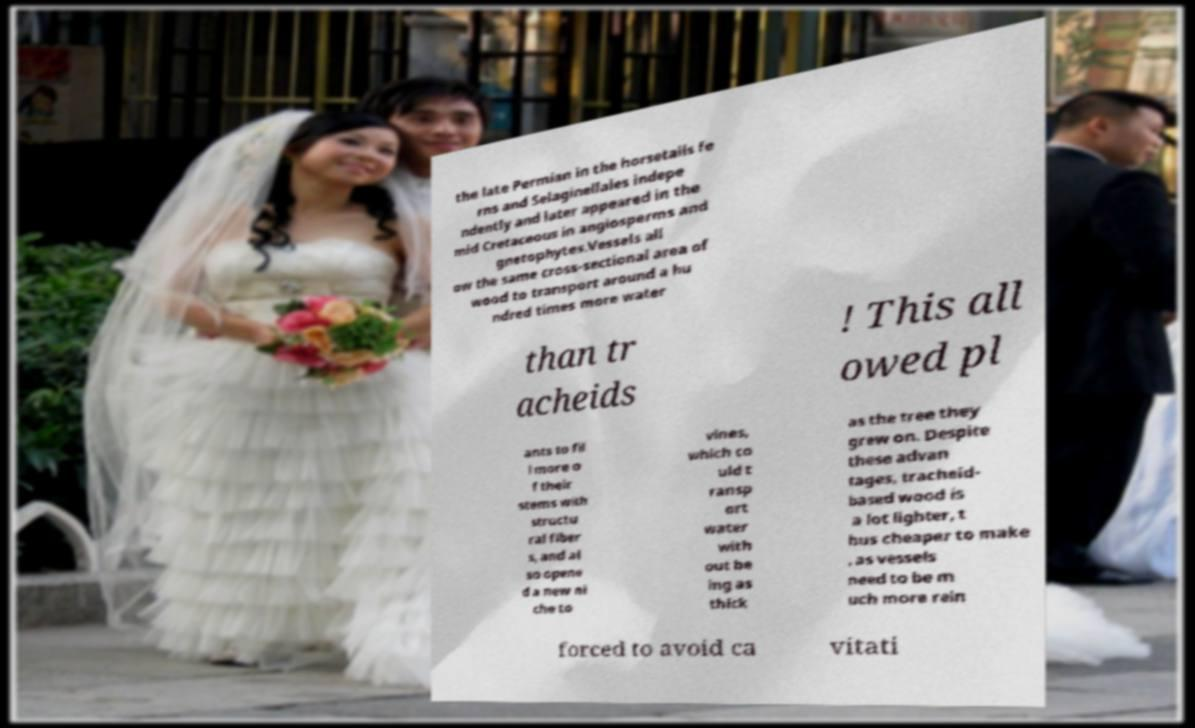Could you assist in decoding the text presented in this image and type it out clearly? the late Permian in the horsetails fe rns and Selaginellales indepe ndently and later appeared in the mid Cretaceous in angiosperms and gnetophytes.Vessels all ow the same cross-sectional area of wood to transport around a hu ndred times more water than tr acheids ! This all owed pl ants to fil l more o f their stems with structu ral fiber s, and al so opene d a new ni che to vines, which co uld t ransp ort water with out be ing as thick as the tree they grew on. Despite these advan tages, tracheid- based wood is a lot lighter, t hus cheaper to make , as vessels need to be m uch more rein forced to avoid ca vitati 